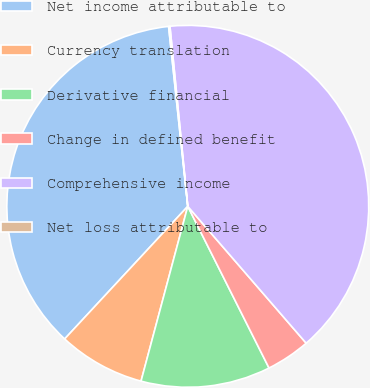<chart> <loc_0><loc_0><loc_500><loc_500><pie_chart><fcel>Net income attributable to<fcel>Currency translation<fcel>Derivative financial<fcel>Change in defined benefit<fcel>Comprehensive income<fcel>Net loss attributable to<nl><fcel>36.4%<fcel>7.75%<fcel>11.57%<fcel>3.94%<fcel>40.22%<fcel>0.12%<nl></chart> 